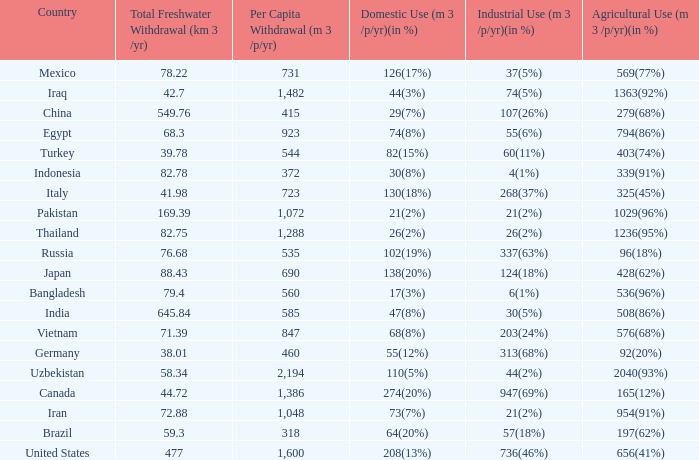What is the highest Per Capita Withdrawal (m 3 /p/yr), when Agricultural Use (m 3 /p/yr)(in %) is 1363(92%), and when Total Freshwater Withdrawal (km 3 /yr) is less than 42.7? None. 